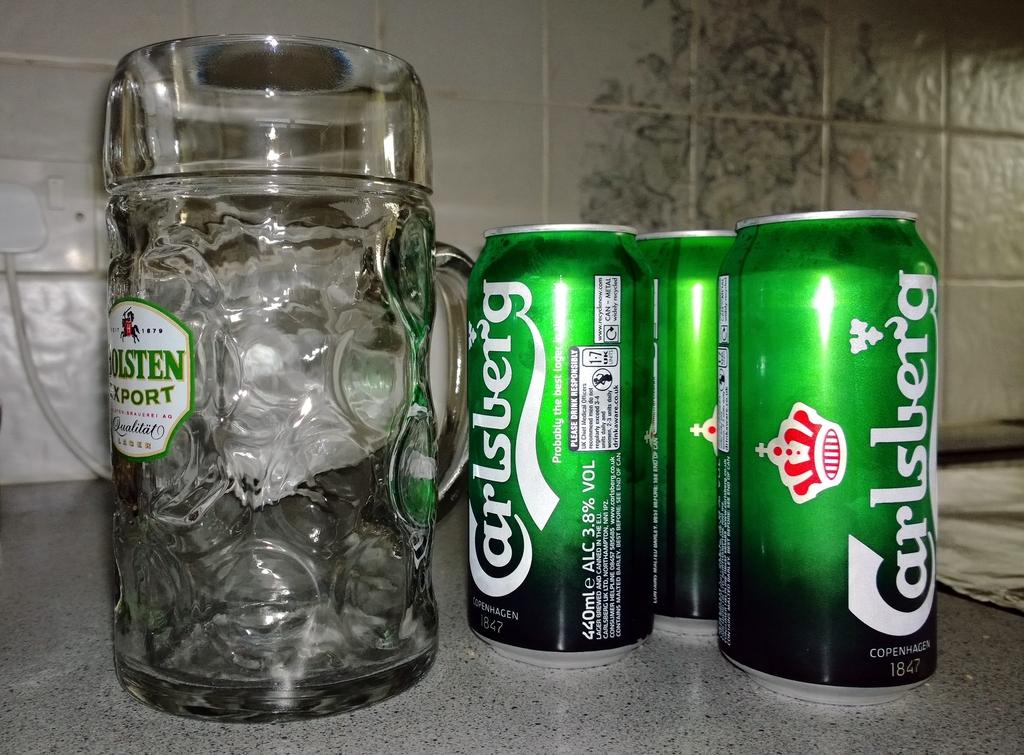What does the can say?
Offer a terse response. Carlsberg. Is this a german brand?
Offer a very short reply. Yes. 